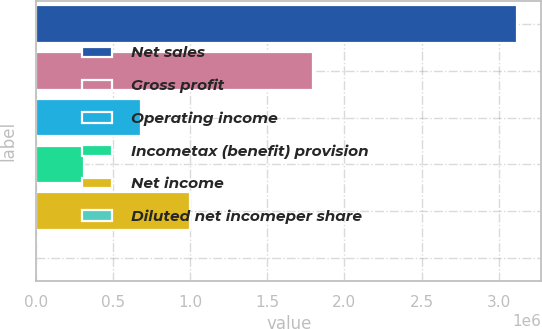<chart> <loc_0><loc_0><loc_500><loc_500><bar_chart><fcel>Net sales<fcel>Gross profit<fcel>Operating income<fcel>Incometax (benefit) provision<fcel>Net income<fcel>Diluted net incomeper share<nl><fcel>3.12156e+06<fcel>1.79794e+06<fcel>683637<fcel>312159<fcel>995793<fcel>3.76<nl></chart> 